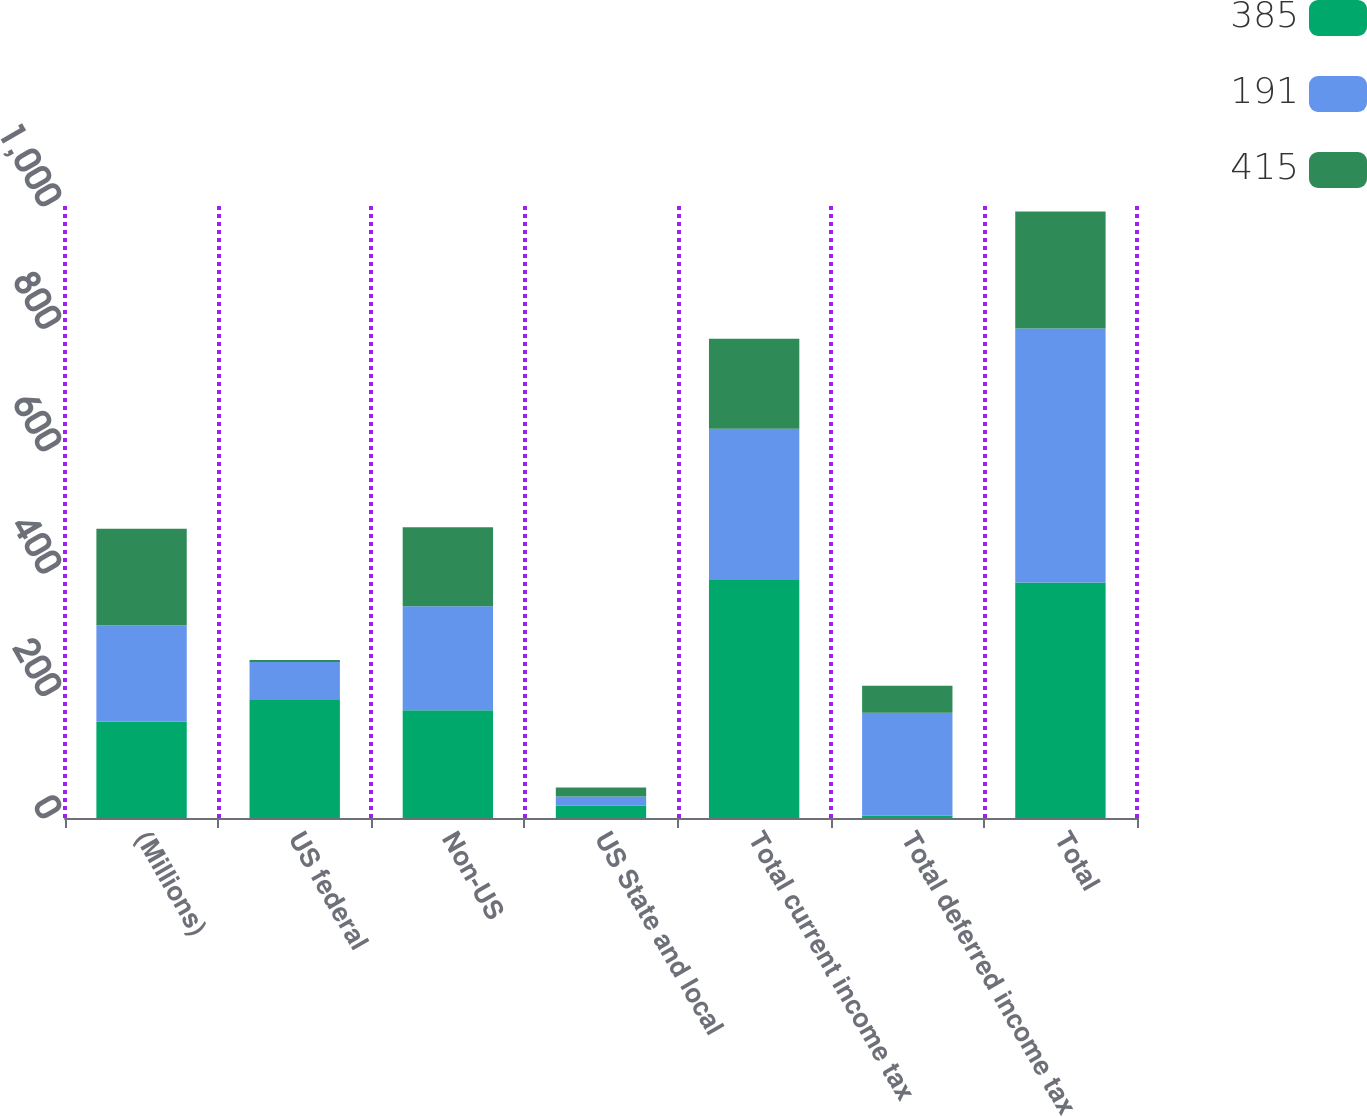Convert chart. <chart><loc_0><loc_0><loc_500><loc_500><stacked_bar_chart><ecel><fcel>(Millions)<fcel>US federal<fcel>Non-US<fcel>US State and local<fcel>Total current income tax<fcel>Total deferred income tax<fcel>Total<nl><fcel>385<fcel>157.5<fcel>193<fcel>176<fcel>20<fcel>389<fcel>4<fcel>385<nl><fcel>191<fcel>157.5<fcel>62<fcel>170<fcel>15<fcel>247<fcel>168<fcel>415<nl><fcel>415<fcel>157.5<fcel>3<fcel>129<fcel>15<fcel>147<fcel>44<fcel>191<nl></chart> 